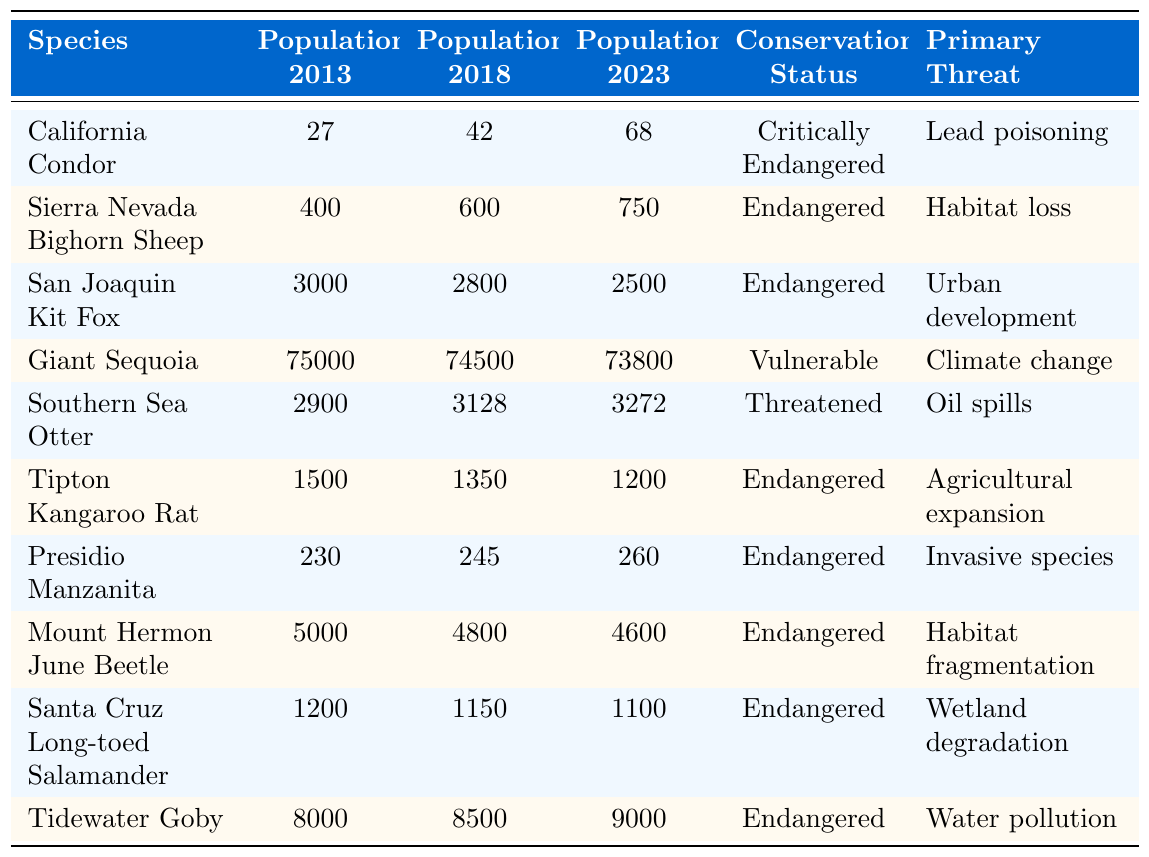What is the population of the California Condor in 2023? The table displays the population of the California Condor listed for the year 2023, which is directly provided in the relevant cell. The value is 68.
Answer: 68 What was the population of the Sierra Nevada Bighorn Sheep in 2018? The population of the Sierra Nevada Bighorn Sheep for the year 2018 can be found in the table, under the corresponding year, which is 600.
Answer: 600 How many endangered species showed an increase in population from 2013 to 2023? To determine the number of endangered species with increased populations, I will examine the population numbers for 2013 and 2023. The species that increased are California Condor, Southern Sea Otter, and Tidewater Goby, giving a total of three.
Answer: 3 What is the primary threat to the San Joaquin Kit Fox? The primary threat is noted in the table under the corresponding column for the San Joaquin Kit Fox. It shows that the primary threat is urban development.
Answer: Urban development Calculate the percentage increase in population for the Southern Sea Otter from 2013 to 2023. First, I find the population in 2013 (2900) and in 2023 (3272). The increase is 3272 - 2900 = 372. The percentage increase is (372/2900) * 100, which calculates to approximately 12.83%.
Answer: 12.83% Is the population of the Tipton Kangaroo Rat decreasing over the years? By comparing the population values year by year, the numbers are 1500 in 2013, 1350 in 2018, and 1200 in 2023, which indicates a decreasing trend.
Answer: Yes How many species have a population less than 1000 in 2023? Checking the population column for 2023, only the Mount Hermon June Beetle (4600), San Joaquin Kit Fox (2500), and others have populations above 1000. None of the species listed have populations below 1000 in 2023.
Answer: 0 What is the total population of all endangered species in 2023? To find this, I sum the populations of all endangered species for 2023 from the table: San Joaquin Kit Fox (2500) + Sierra Nevada Bighorn Sheep (750) + Tipton Kangaroo Rat (1200) + Presidio Manzanita (260) + Mount Hermon June Beetle (4600) + Santa Cruz Long-toed Salamander (1100) + Tidewater Goby (9000). This results in a total of 25,410.
Answer: 25410 Which species had the highest population in 2013? I look through the 'Population 2013' column in the table to find the maximum value. The Giant Sequoia shows the highest population count of 75,000 in 2013.
Answer: Giant Sequoia Among the listed species, which one has improved its conservation status over the decade? I analyze each species' conservation status over the years to see if any indicate an improvement. The table shows that the California Condor had previously a lower population and is gradually increasing, but all species listed still retain their initial status.
Answer: None 